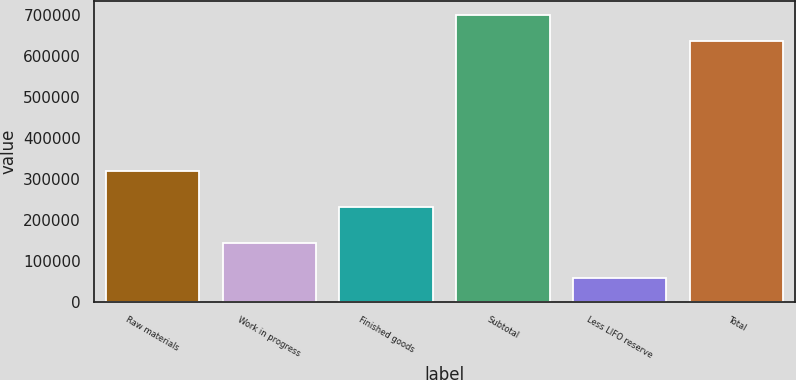<chart> <loc_0><loc_0><loc_500><loc_500><bar_chart><fcel>Raw materials<fcel>Work in progress<fcel>Finished goods<fcel>Subtotal<fcel>Less LIFO reserve<fcel>Total<nl><fcel>319407<fcel>144017<fcel>231507<fcel>699733<fcel>58810<fcel>636121<nl></chart> 